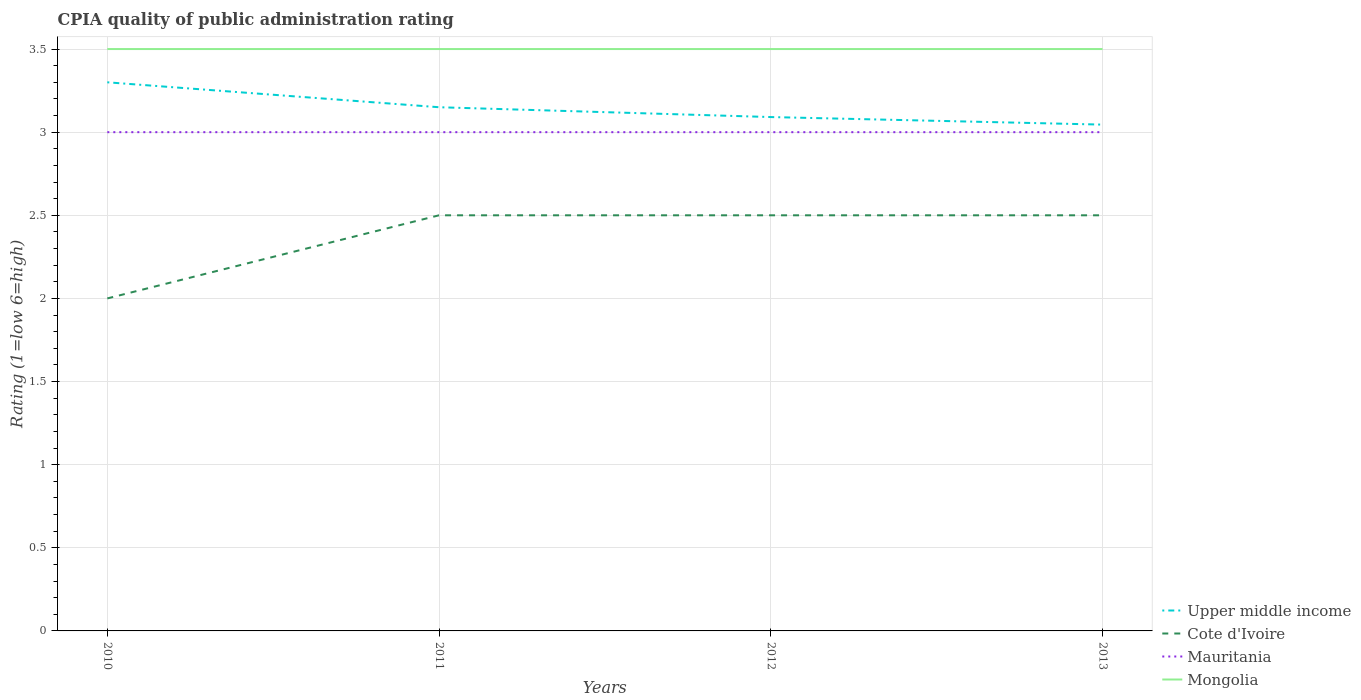How many different coloured lines are there?
Offer a terse response. 4. Does the line corresponding to Mongolia intersect with the line corresponding to Upper middle income?
Provide a short and direct response. No. Across all years, what is the maximum CPIA rating in Cote d'Ivoire?
Ensure brevity in your answer.  2. What is the total CPIA rating in Cote d'Ivoire in the graph?
Your answer should be compact. 0. What is the difference between the highest and the second highest CPIA rating in Upper middle income?
Give a very brief answer. 0.25. Is the CPIA rating in Cote d'Ivoire strictly greater than the CPIA rating in Mongolia over the years?
Your answer should be very brief. Yes. Does the graph contain any zero values?
Your response must be concise. No. Where does the legend appear in the graph?
Ensure brevity in your answer.  Bottom right. How are the legend labels stacked?
Offer a terse response. Vertical. What is the title of the graph?
Keep it short and to the point. CPIA quality of public administration rating. Does "Sub-Saharan Africa (developing only)" appear as one of the legend labels in the graph?
Keep it short and to the point. No. What is the label or title of the X-axis?
Make the answer very short. Years. What is the Rating (1=low 6=high) of Upper middle income in 2010?
Provide a short and direct response. 3.3. What is the Rating (1=low 6=high) of Cote d'Ivoire in 2010?
Keep it short and to the point. 2. What is the Rating (1=low 6=high) of Mauritania in 2010?
Ensure brevity in your answer.  3. What is the Rating (1=low 6=high) of Upper middle income in 2011?
Your answer should be very brief. 3.15. What is the Rating (1=low 6=high) in Cote d'Ivoire in 2011?
Your answer should be very brief. 2.5. What is the Rating (1=low 6=high) of Upper middle income in 2012?
Offer a terse response. 3.09. What is the Rating (1=low 6=high) of Cote d'Ivoire in 2012?
Make the answer very short. 2.5. What is the Rating (1=low 6=high) in Mauritania in 2012?
Give a very brief answer. 3. What is the Rating (1=low 6=high) of Upper middle income in 2013?
Make the answer very short. 3.05. What is the Rating (1=low 6=high) in Cote d'Ivoire in 2013?
Provide a short and direct response. 2.5. Across all years, what is the maximum Rating (1=low 6=high) of Upper middle income?
Provide a succinct answer. 3.3. Across all years, what is the maximum Rating (1=low 6=high) in Cote d'Ivoire?
Offer a terse response. 2.5. Across all years, what is the maximum Rating (1=low 6=high) in Mauritania?
Provide a short and direct response. 3. Across all years, what is the maximum Rating (1=low 6=high) in Mongolia?
Make the answer very short. 3.5. Across all years, what is the minimum Rating (1=low 6=high) of Upper middle income?
Ensure brevity in your answer.  3.05. Across all years, what is the minimum Rating (1=low 6=high) of Cote d'Ivoire?
Your answer should be compact. 2. Across all years, what is the minimum Rating (1=low 6=high) of Mauritania?
Offer a very short reply. 3. What is the total Rating (1=low 6=high) of Upper middle income in the graph?
Provide a succinct answer. 12.59. What is the total Rating (1=low 6=high) in Cote d'Ivoire in the graph?
Give a very brief answer. 9.5. What is the total Rating (1=low 6=high) in Mongolia in the graph?
Make the answer very short. 14. What is the difference between the Rating (1=low 6=high) of Upper middle income in 2010 and that in 2011?
Provide a succinct answer. 0.15. What is the difference between the Rating (1=low 6=high) in Mongolia in 2010 and that in 2011?
Give a very brief answer. 0. What is the difference between the Rating (1=low 6=high) of Upper middle income in 2010 and that in 2012?
Your answer should be compact. 0.21. What is the difference between the Rating (1=low 6=high) in Mauritania in 2010 and that in 2012?
Your answer should be compact. 0. What is the difference between the Rating (1=low 6=high) in Upper middle income in 2010 and that in 2013?
Your answer should be very brief. 0.25. What is the difference between the Rating (1=low 6=high) in Mauritania in 2010 and that in 2013?
Offer a terse response. 0. What is the difference between the Rating (1=low 6=high) of Upper middle income in 2011 and that in 2012?
Ensure brevity in your answer.  0.06. What is the difference between the Rating (1=low 6=high) in Upper middle income in 2011 and that in 2013?
Offer a very short reply. 0.1. What is the difference between the Rating (1=low 6=high) of Cote d'Ivoire in 2011 and that in 2013?
Your response must be concise. 0. What is the difference between the Rating (1=low 6=high) of Mauritania in 2011 and that in 2013?
Your answer should be compact. 0. What is the difference between the Rating (1=low 6=high) in Mongolia in 2011 and that in 2013?
Offer a very short reply. 0. What is the difference between the Rating (1=low 6=high) in Upper middle income in 2012 and that in 2013?
Your answer should be very brief. 0.05. What is the difference between the Rating (1=low 6=high) of Upper middle income in 2010 and the Rating (1=low 6=high) of Cote d'Ivoire in 2011?
Make the answer very short. 0.8. What is the difference between the Rating (1=low 6=high) of Cote d'Ivoire in 2010 and the Rating (1=low 6=high) of Mongolia in 2011?
Offer a very short reply. -1.5. What is the difference between the Rating (1=low 6=high) of Upper middle income in 2010 and the Rating (1=low 6=high) of Cote d'Ivoire in 2012?
Offer a very short reply. 0.8. What is the difference between the Rating (1=low 6=high) in Cote d'Ivoire in 2010 and the Rating (1=low 6=high) in Mauritania in 2012?
Offer a very short reply. -1. What is the difference between the Rating (1=low 6=high) in Cote d'Ivoire in 2010 and the Rating (1=low 6=high) in Mongolia in 2012?
Provide a short and direct response. -1.5. What is the difference between the Rating (1=low 6=high) of Mauritania in 2010 and the Rating (1=low 6=high) of Mongolia in 2012?
Offer a terse response. -0.5. What is the difference between the Rating (1=low 6=high) of Upper middle income in 2010 and the Rating (1=low 6=high) of Cote d'Ivoire in 2013?
Make the answer very short. 0.8. What is the difference between the Rating (1=low 6=high) in Upper middle income in 2010 and the Rating (1=low 6=high) in Mauritania in 2013?
Ensure brevity in your answer.  0.3. What is the difference between the Rating (1=low 6=high) in Upper middle income in 2010 and the Rating (1=low 6=high) in Mongolia in 2013?
Ensure brevity in your answer.  -0.2. What is the difference between the Rating (1=low 6=high) in Mauritania in 2010 and the Rating (1=low 6=high) in Mongolia in 2013?
Your answer should be compact. -0.5. What is the difference between the Rating (1=low 6=high) of Upper middle income in 2011 and the Rating (1=low 6=high) of Cote d'Ivoire in 2012?
Your answer should be very brief. 0.65. What is the difference between the Rating (1=low 6=high) of Upper middle income in 2011 and the Rating (1=low 6=high) of Mongolia in 2012?
Provide a short and direct response. -0.35. What is the difference between the Rating (1=low 6=high) in Cote d'Ivoire in 2011 and the Rating (1=low 6=high) in Mauritania in 2012?
Offer a very short reply. -0.5. What is the difference between the Rating (1=low 6=high) in Cote d'Ivoire in 2011 and the Rating (1=low 6=high) in Mongolia in 2012?
Ensure brevity in your answer.  -1. What is the difference between the Rating (1=low 6=high) in Upper middle income in 2011 and the Rating (1=low 6=high) in Cote d'Ivoire in 2013?
Your answer should be very brief. 0.65. What is the difference between the Rating (1=low 6=high) of Upper middle income in 2011 and the Rating (1=low 6=high) of Mauritania in 2013?
Provide a short and direct response. 0.15. What is the difference between the Rating (1=low 6=high) of Upper middle income in 2011 and the Rating (1=low 6=high) of Mongolia in 2013?
Give a very brief answer. -0.35. What is the difference between the Rating (1=low 6=high) in Cote d'Ivoire in 2011 and the Rating (1=low 6=high) in Mauritania in 2013?
Give a very brief answer. -0.5. What is the difference between the Rating (1=low 6=high) of Upper middle income in 2012 and the Rating (1=low 6=high) of Cote d'Ivoire in 2013?
Your answer should be very brief. 0.59. What is the difference between the Rating (1=low 6=high) of Upper middle income in 2012 and the Rating (1=low 6=high) of Mauritania in 2013?
Provide a short and direct response. 0.09. What is the difference between the Rating (1=low 6=high) of Upper middle income in 2012 and the Rating (1=low 6=high) of Mongolia in 2013?
Offer a terse response. -0.41. What is the difference between the Rating (1=low 6=high) in Cote d'Ivoire in 2012 and the Rating (1=low 6=high) in Mauritania in 2013?
Your answer should be very brief. -0.5. What is the difference between the Rating (1=low 6=high) of Mauritania in 2012 and the Rating (1=low 6=high) of Mongolia in 2013?
Give a very brief answer. -0.5. What is the average Rating (1=low 6=high) of Upper middle income per year?
Give a very brief answer. 3.15. What is the average Rating (1=low 6=high) in Cote d'Ivoire per year?
Provide a succinct answer. 2.38. What is the average Rating (1=low 6=high) of Mauritania per year?
Your answer should be very brief. 3. In the year 2010, what is the difference between the Rating (1=low 6=high) of Upper middle income and Rating (1=low 6=high) of Mongolia?
Provide a succinct answer. -0.2. In the year 2010, what is the difference between the Rating (1=low 6=high) in Cote d'Ivoire and Rating (1=low 6=high) in Mauritania?
Provide a short and direct response. -1. In the year 2010, what is the difference between the Rating (1=low 6=high) in Cote d'Ivoire and Rating (1=low 6=high) in Mongolia?
Ensure brevity in your answer.  -1.5. In the year 2010, what is the difference between the Rating (1=low 6=high) of Mauritania and Rating (1=low 6=high) of Mongolia?
Your response must be concise. -0.5. In the year 2011, what is the difference between the Rating (1=low 6=high) of Upper middle income and Rating (1=low 6=high) of Cote d'Ivoire?
Your response must be concise. 0.65. In the year 2011, what is the difference between the Rating (1=low 6=high) in Upper middle income and Rating (1=low 6=high) in Mongolia?
Give a very brief answer. -0.35. In the year 2011, what is the difference between the Rating (1=low 6=high) of Cote d'Ivoire and Rating (1=low 6=high) of Mauritania?
Offer a very short reply. -0.5. In the year 2012, what is the difference between the Rating (1=low 6=high) of Upper middle income and Rating (1=low 6=high) of Cote d'Ivoire?
Give a very brief answer. 0.59. In the year 2012, what is the difference between the Rating (1=low 6=high) in Upper middle income and Rating (1=low 6=high) in Mauritania?
Keep it short and to the point. 0.09. In the year 2012, what is the difference between the Rating (1=low 6=high) in Upper middle income and Rating (1=low 6=high) in Mongolia?
Your answer should be compact. -0.41. In the year 2012, what is the difference between the Rating (1=low 6=high) in Cote d'Ivoire and Rating (1=low 6=high) in Mongolia?
Your answer should be compact. -1. In the year 2013, what is the difference between the Rating (1=low 6=high) of Upper middle income and Rating (1=low 6=high) of Cote d'Ivoire?
Keep it short and to the point. 0.55. In the year 2013, what is the difference between the Rating (1=low 6=high) in Upper middle income and Rating (1=low 6=high) in Mauritania?
Make the answer very short. 0.05. In the year 2013, what is the difference between the Rating (1=low 6=high) of Upper middle income and Rating (1=low 6=high) of Mongolia?
Offer a very short reply. -0.45. In the year 2013, what is the difference between the Rating (1=low 6=high) in Mauritania and Rating (1=low 6=high) in Mongolia?
Your answer should be very brief. -0.5. What is the ratio of the Rating (1=low 6=high) in Upper middle income in 2010 to that in 2011?
Offer a terse response. 1.05. What is the ratio of the Rating (1=low 6=high) in Cote d'Ivoire in 2010 to that in 2011?
Offer a terse response. 0.8. What is the ratio of the Rating (1=low 6=high) of Mauritania in 2010 to that in 2011?
Offer a very short reply. 1. What is the ratio of the Rating (1=low 6=high) in Upper middle income in 2010 to that in 2012?
Your answer should be very brief. 1.07. What is the ratio of the Rating (1=low 6=high) in Cote d'Ivoire in 2010 to that in 2012?
Give a very brief answer. 0.8. What is the ratio of the Rating (1=low 6=high) in Mauritania in 2010 to that in 2012?
Provide a short and direct response. 1. What is the ratio of the Rating (1=low 6=high) in Mongolia in 2010 to that in 2012?
Offer a very short reply. 1. What is the ratio of the Rating (1=low 6=high) in Upper middle income in 2010 to that in 2013?
Your response must be concise. 1.08. What is the ratio of the Rating (1=low 6=high) in Cote d'Ivoire in 2010 to that in 2013?
Offer a terse response. 0.8. What is the ratio of the Rating (1=low 6=high) of Upper middle income in 2011 to that in 2012?
Provide a short and direct response. 1.02. What is the ratio of the Rating (1=low 6=high) in Mongolia in 2011 to that in 2012?
Give a very brief answer. 1. What is the ratio of the Rating (1=low 6=high) of Upper middle income in 2011 to that in 2013?
Offer a terse response. 1.03. What is the ratio of the Rating (1=low 6=high) of Cote d'Ivoire in 2011 to that in 2013?
Make the answer very short. 1. What is the ratio of the Rating (1=low 6=high) of Upper middle income in 2012 to that in 2013?
Provide a succinct answer. 1.01. What is the ratio of the Rating (1=low 6=high) of Cote d'Ivoire in 2012 to that in 2013?
Offer a terse response. 1. What is the ratio of the Rating (1=low 6=high) in Mauritania in 2012 to that in 2013?
Keep it short and to the point. 1. What is the difference between the highest and the second highest Rating (1=low 6=high) in Upper middle income?
Give a very brief answer. 0.15. What is the difference between the highest and the second highest Rating (1=low 6=high) in Mauritania?
Provide a short and direct response. 0. What is the difference between the highest and the second highest Rating (1=low 6=high) of Mongolia?
Your answer should be compact. 0. What is the difference between the highest and the lowest Rating (1=low 6=high) of Upper middle income?
Offer a very short reply. 0.25. What is the difference between the highest and the lowest Rating (1=low 6=high) in Cote d'Ivoire?
Offer a terse response. 0.5. 